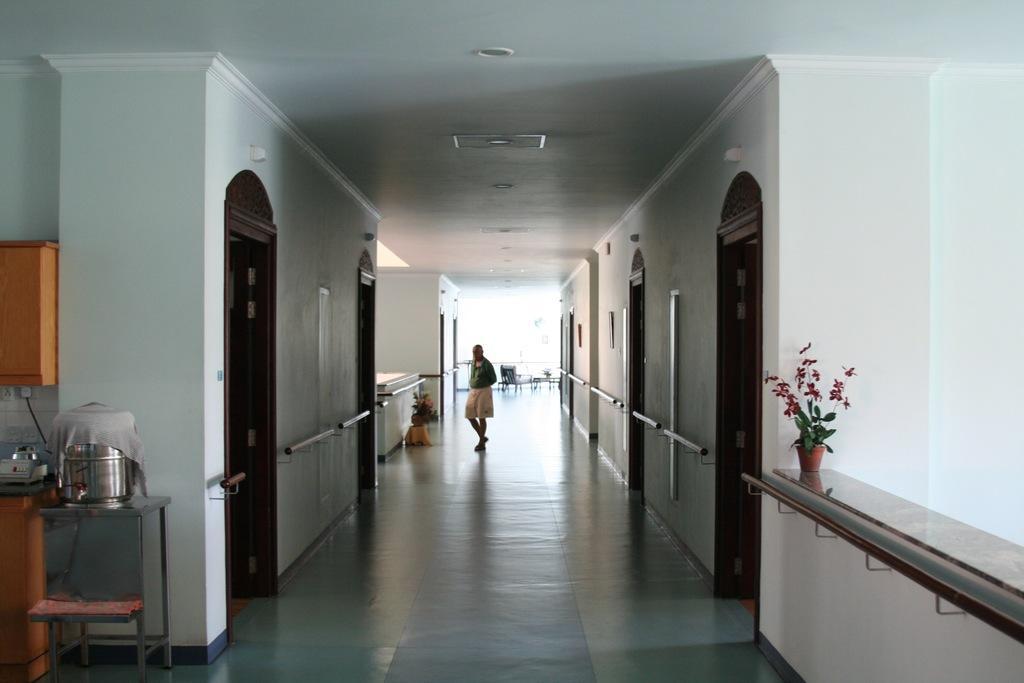In one or two sentences, can you explain what this image depicts? In this image, I can see a person standing. I think these are the rooms with doors. These look like the staircase holders, which are attached to the walls. I can see the flower pots with the plants. On the right side of the image, I can see the water filter. This looks like a cupboard, which is attached to a wall. I think these are the ceiling lights, which are attached to the ceiling. 